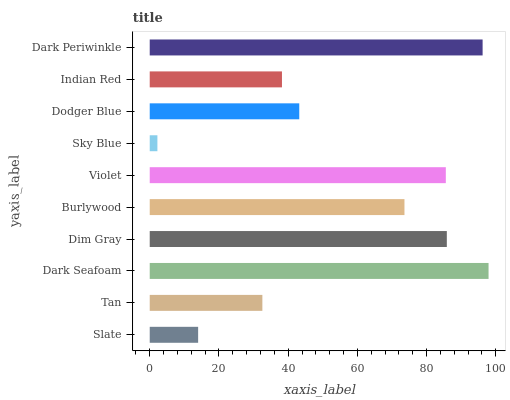Is Sky Blue the minimum?
Answer yes or no. Yes. Is Dark Seafoam the maximum?
Answer yes or no. Yes. Is Tan the minimum?
Answer yes or no. No. Is Tan the maximum?
Answer yes or no. No. Is Tan greater than Slate?
Answer yes or no. Yes. Is Slate less than Tan?
Answer yes or no. Yes. Is Slate greater than Tan?
Answer yes or no. No. Is Tan less than Slate?
Answer yes or no. No. Is Burlywood the high median?
Answer yes or no. Yes. Is Dodger Blue the low median?
Answer yes or no. Yes. Is Dim Gray the high median?
Answer yes or no. No. Is Violet the low median?
Answer yes or no. No. 